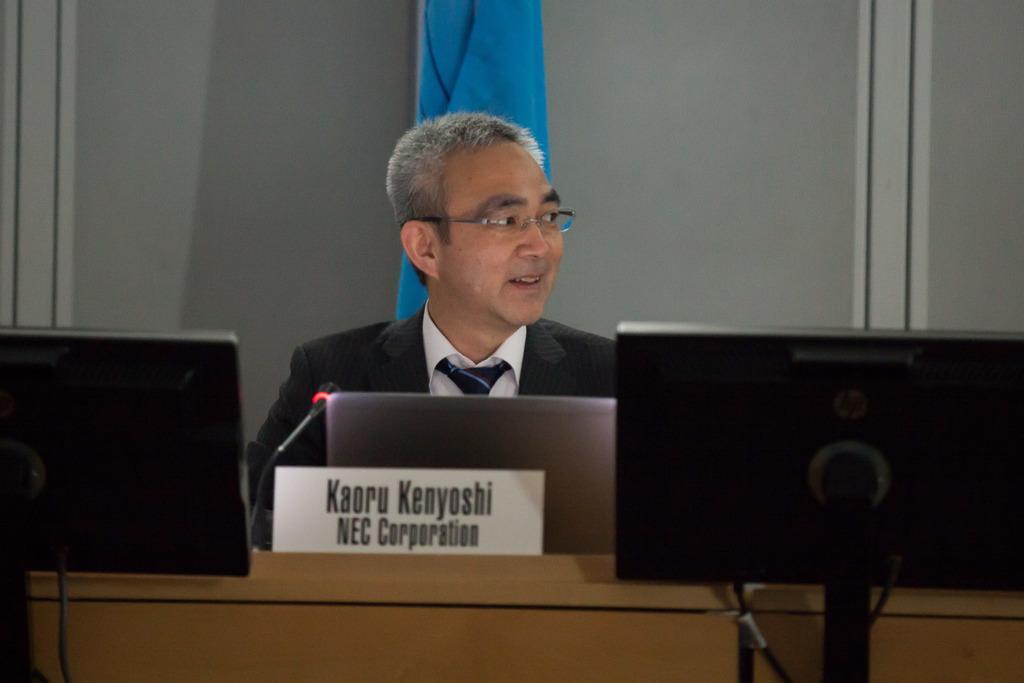Could you give a brief overview of what you see in this image? In this image I can see a person wearing white shirt, black tie and black blazer. I can see a desk in front of him and on it I can see a laptop, a microphone and a white colored board. I can see two black colored screens in front of him. In the background I can see the grey colored wall and a blue colored cloth. 